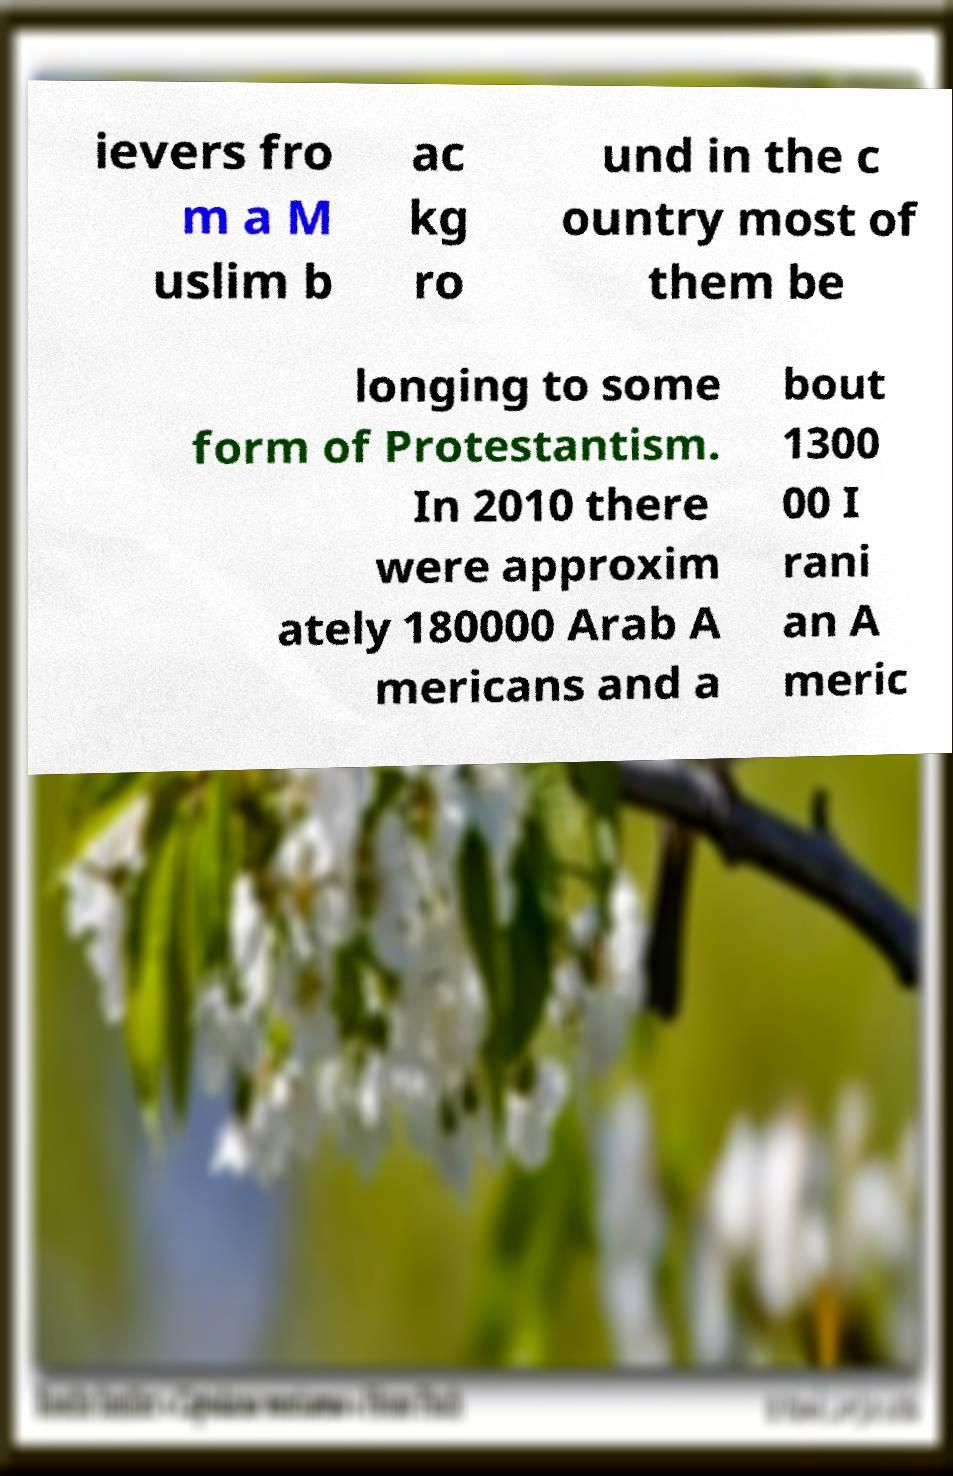I need the written content from this picture converted into text. Can you do that? ievers fro m a M uslim b ac kg ro und in the c ountry most of them be longing to some form of Protestantism. In 2010 there were approxim ately 180000 Arab A mericans and a bout 1300 00 I rani an A meric 